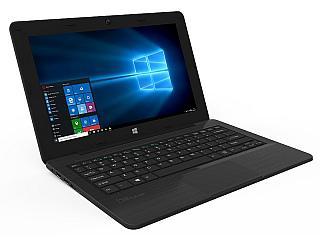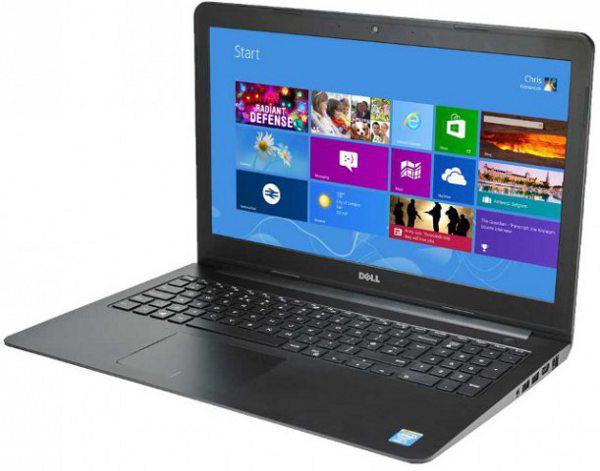The first image is the image on the left, the second image is the image on the right. For the images shown, is this caption "The right image features three opened laptops." true? Answer yes or no. No. The first image is the image on the left, the second image is the image on the right. Evaluate the accuracy of this statement regarding the images: "The right image depicts three laptops.". Is it true? Answer yes or no. No. 